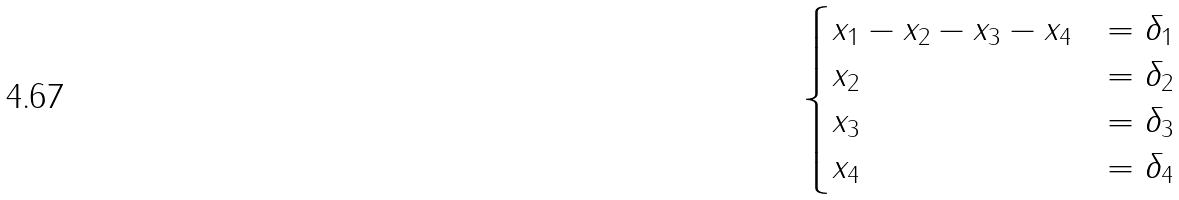<formula> <loc_0><loc_0><loc_500><loc_500>\begin{cases} x _ { 1 } - x _ { 2 } - x _ { 3 } - x _ { 4 } & = \delta _ { 1 } \\ x _ { 2 } & = \delta _ { 2 } \\ x _ { 3 } & = \delta _ { 3 } \\ x _ { 4 } & = \delta _ { 4 } \\ \end{cases}</formula> 